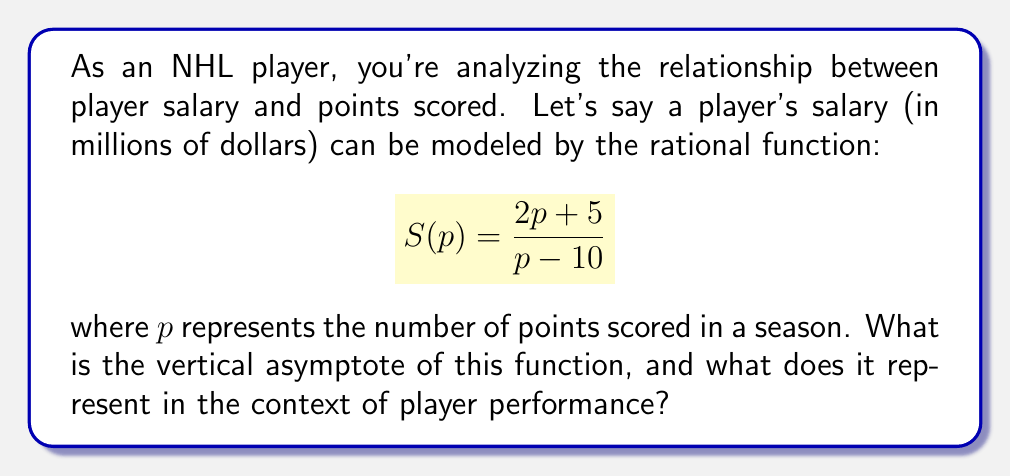Can you answer this question? To find the vertical asymptote, we need to determine where the denominator of the rational function equals zero.

1) Set the denominator equal to zero:
   $p - 10 = 0$

2) Solve for $p$:
   $p = 10$

3) Interpret the result:
   The vertical asymptote occurs at $p = 10$. In the context of player performance, this means:

   a) The function is undefined when a player scores exactly 10 points.
   b) As a player's point total approaches 10 (from either direction), their salary would theoretically approach infinity.
   c) The model suggests that players scoring less than 10 points would have negative salaries, which is not realistic.

4) Real-world interpretation:
   This asymptote might represent a critical threshold in player performance. Players scoring significantly more than 10 points are likely to see substantial salary increases, while those scoring fewer may struggle to maintain high salaries or even remain in the league.
Answer: $p = 10$ 